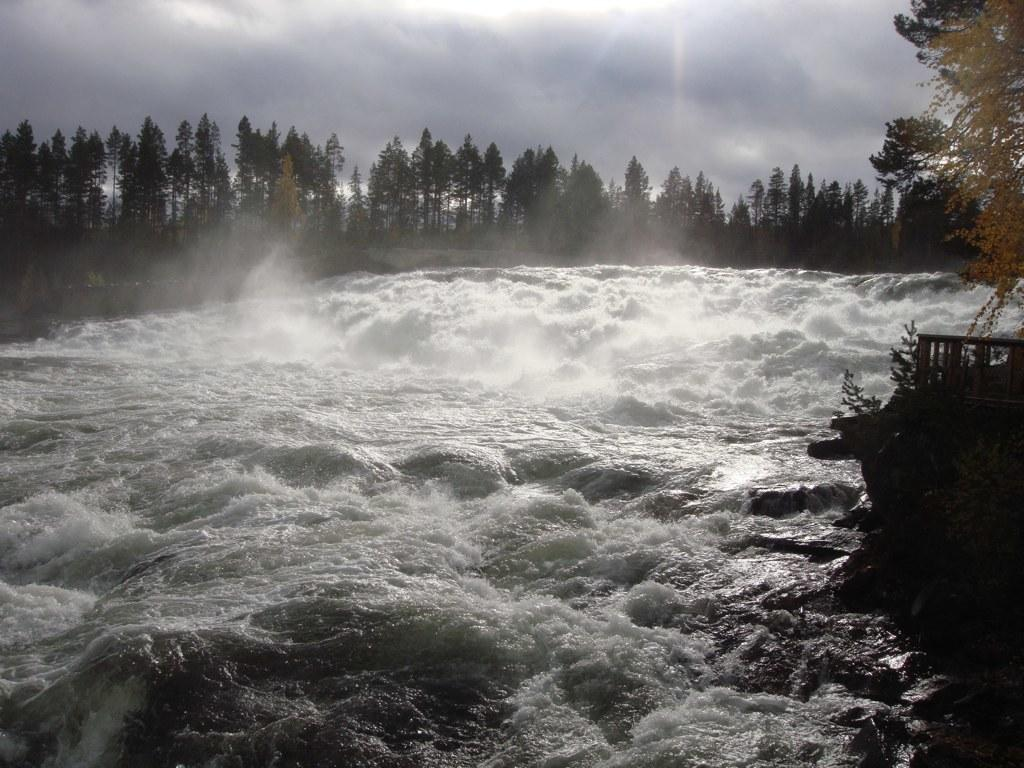What is the primary element flowing in the image? There is water flowing in the image. What type of vegetation can be seen in the image? There are trees visible in the image. What is located on the right side of the image? There is a small fence on the right side of the image. What is the condition of the sky in the image? The sky is cloudy in the image. What type of insect can be seen crawling on the neck of the person in the image? There is no person present in the image, and therefore no neck or insect can be observed. 